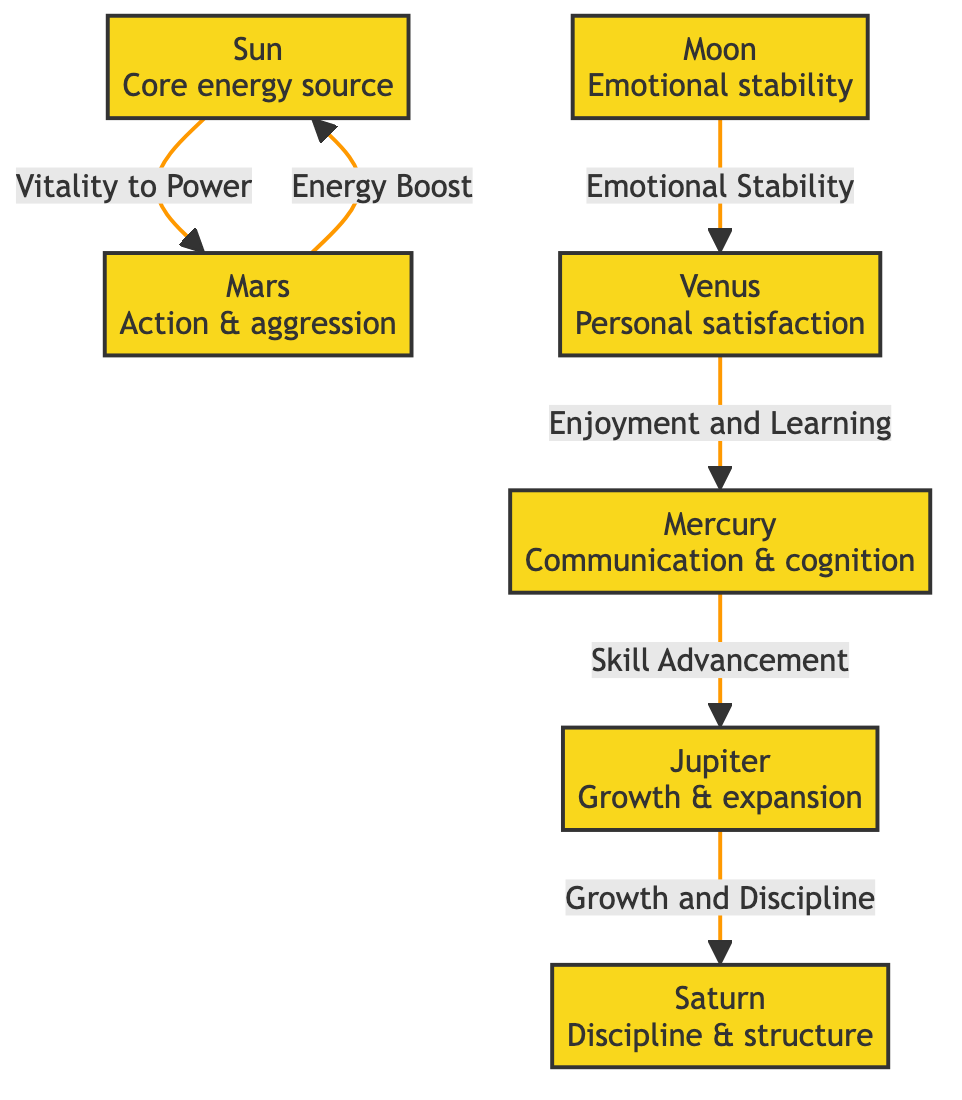What influence does the Sun have on Mars? The diagram indicates a direct connection where the Sun provides "Vitality to Power," influencing Mars. This shows that the Sun's role is to enhance Mars' qualities related to action and aggression.
Answer: Vitality to Power How many nodes are present in the diagram? Counting each unique celestial body listed, there are a total of 7 nodes in the diagram: Sun, Moon, Mars, Jupiter, Saturn, Venus, and Mercury.
Answer: 7 What is the relationship between Jupiter and Saturn? The diagram shows a connection where Jupiter contributes to "Growth and Discipline," which directly influences Saturn. Thus, Jupiter plays a crucial role in fostering the discipline associated with Saturn.
Answer: Growth and Discipline Which planet is associated with emotional stability? The Moon is specifically linked to "Emotional Stability" in the diagram, highlighting its influence on emotional aspects relevant to motivation and energy.
Answer: Moon How does Venus affect Mercury according to the diagram? Venus is connected to Mercury with the notion of "Enjoyment and Learning." This signifies that Venus enhances Mercury's attributes concerning communication and cognitive skills through enjoyment.
Answer: Enjoyment and Learning What is the primary influence of Mars as per the diagram? The diagram illustrates that Mars receives an "Energy Boost" from the Sun, indicating that Mars is primarily influenced by this energy source to enhance its aggressive and action-oriented traits.
Answer: Energy Boost What influences communication and cognition? Mercury is linked to "Communication & cognition" as its intrinsic qualities in the diagram, and it also receives influence from Jupiter via "Skill Advancement." Thus, both aspects converge at Mercury.
Answer: Communication & cognition How many direct connections does the Moon have? The Moon has one direct connection to Venus, which represents the flow of influence from one planet to another based on emotional stability.
Answer: 1 